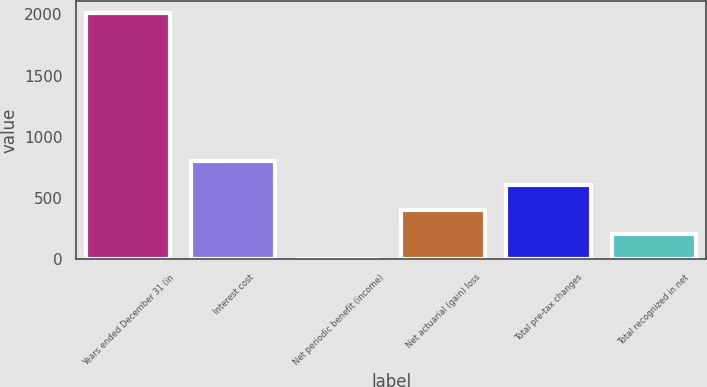<chart> <loc_0><loc_0><loc_500><loc_500><bar_chart><fcel>Years ended December 31 (in<fcel>Interest cost<fcel>Net periodic benefit (income)<fcel>Net actuarial (gain) loss<fcel>Total pre-tax changes<fcel>Total recognized in net<nl><fcel>2012<fcel>806.72<fcel>3.2<fcel>404.96<fcel>605.84<fcel>204.08<nl></chart> 